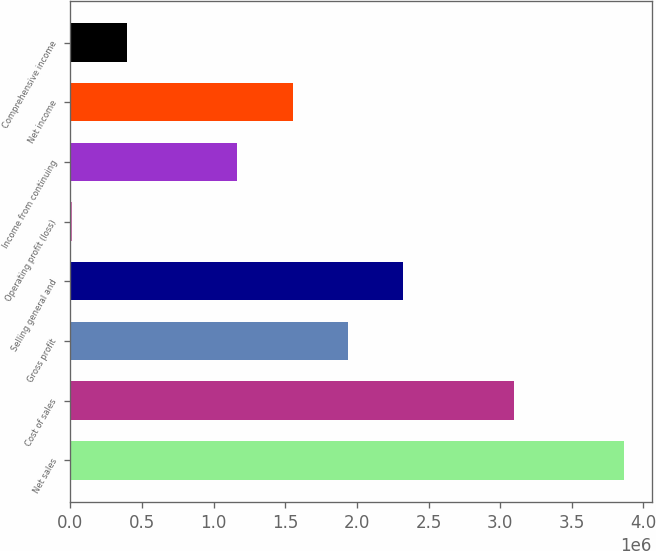Convert chart to OTSL. <chart><loc_0><loc_0><loc_500><loc_500><bar_chart><fcel>Net sales<fcel>Cost of sales<fcel>Gross profit<fcel>Selling general and<fcel>Operating profit (loss)<fcel>Income from continuing<fcel>Net income<fcel>Comprehensive income<nl><fcel>3.86421e+06<fcel>3.0988e+06<fcel>1.93706e+06<fcel>2.32249e+06<fcel>9906<fcel>1.1662e+06<fcel>1.55163e+06<fcel>395336<nl></chart> 